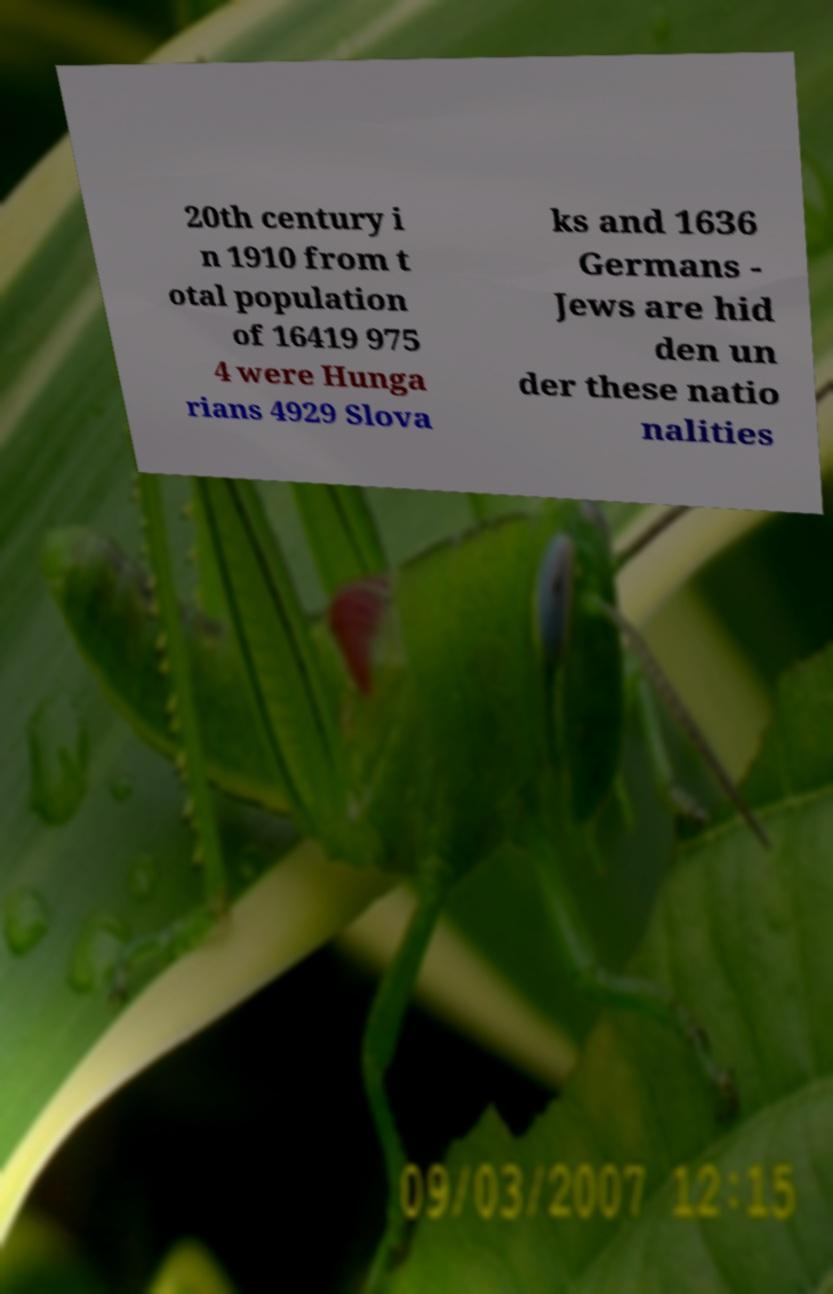There's text embedded in this image that I need extracted. Can you transcribe it verbatim? 20th century i n 1910 from t otal population of 16419 975 4 were Hunga rians 4929 Slova ks and 1636 Germans - Jews are hid den un der these natio nalities 